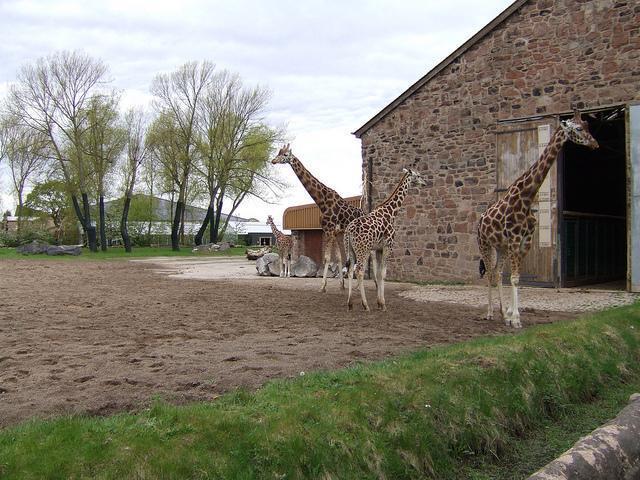How many giraffes are shown?
Give a very brief answer. 4. How many windows are in the top of the building?
Give a very brief answer. 0. How many giraffes are there?
Give a very brief answer. 3. How many train cars are there?
Give a very brief answer. 0. 